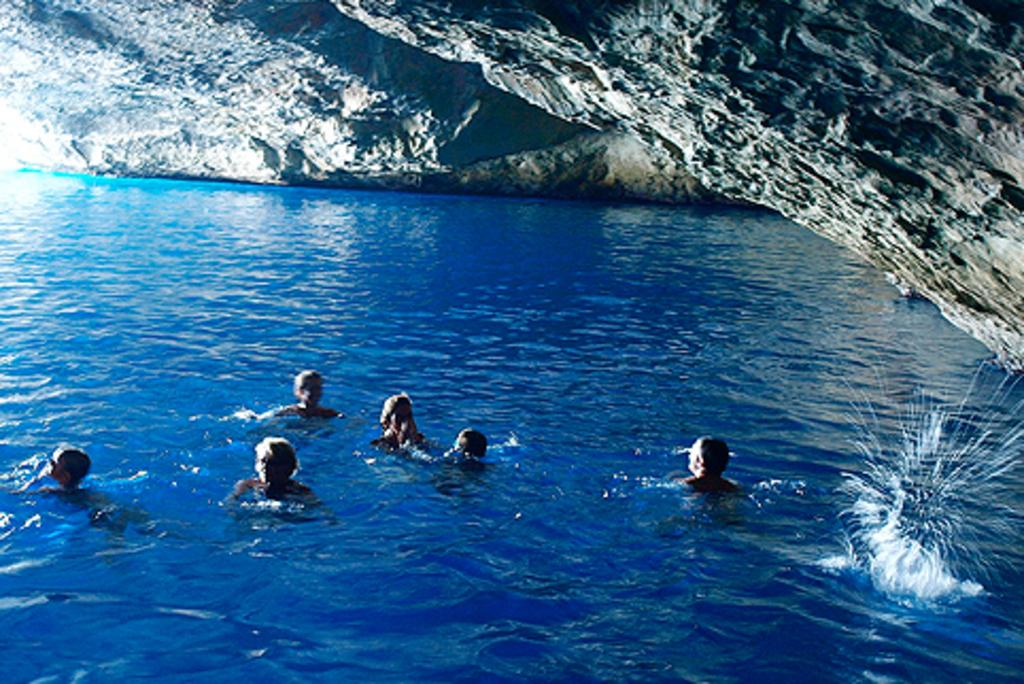What is the main element in the image? There is water in the image. What is the color of the water? The water is blue in color. What are the people in the image doing? There are people swimming in the water. What can be seen beside the water? There is a rock hill beside the water. Can you tell me how many guitars are being played by the people swimming in the image? There are no guitars present in the image; the people are swimming in the water. What type of tiger can be seen hiding behind the rock hill in the image? There is no tiger present in the image; only the water, people swimming, and the rock hill are visible. 